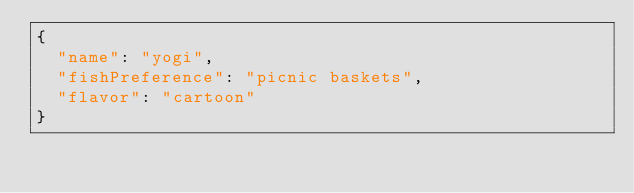Convert code to text. <code><loc_0><loc_0><loc_500><loc_500><_JavaScript_>{
  "name": "yogi",
  "fishPreference": "picnic baskets",
  "flavor": "cartoon"
}
</code> 